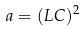<formula> <loc_0><loc_0><loc_500><loc_500>a = ( L C ) ^ { 2 }</formula> 